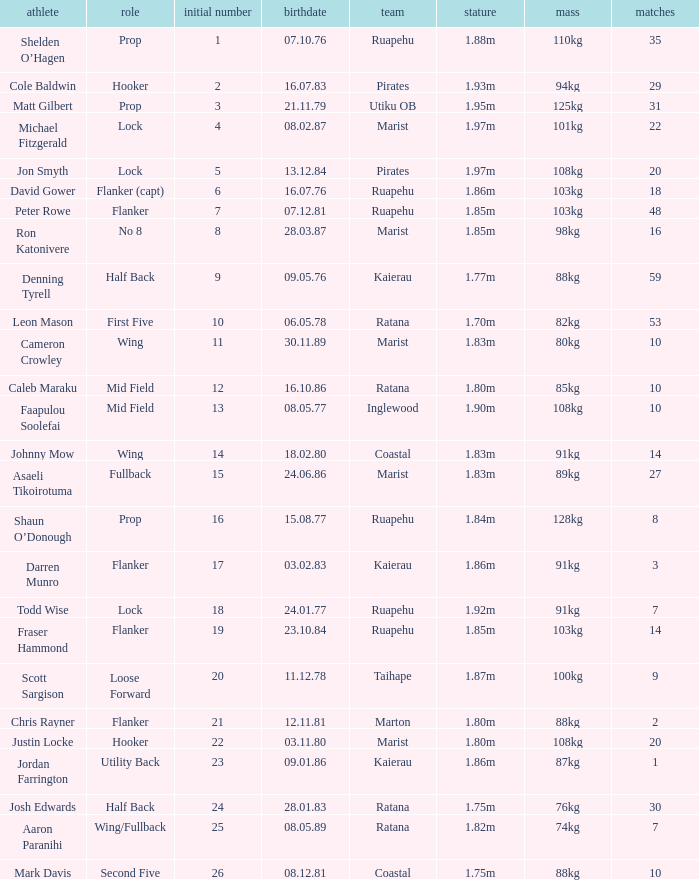What is the date of birth for the player in the Inglewood club? 80577.0. 